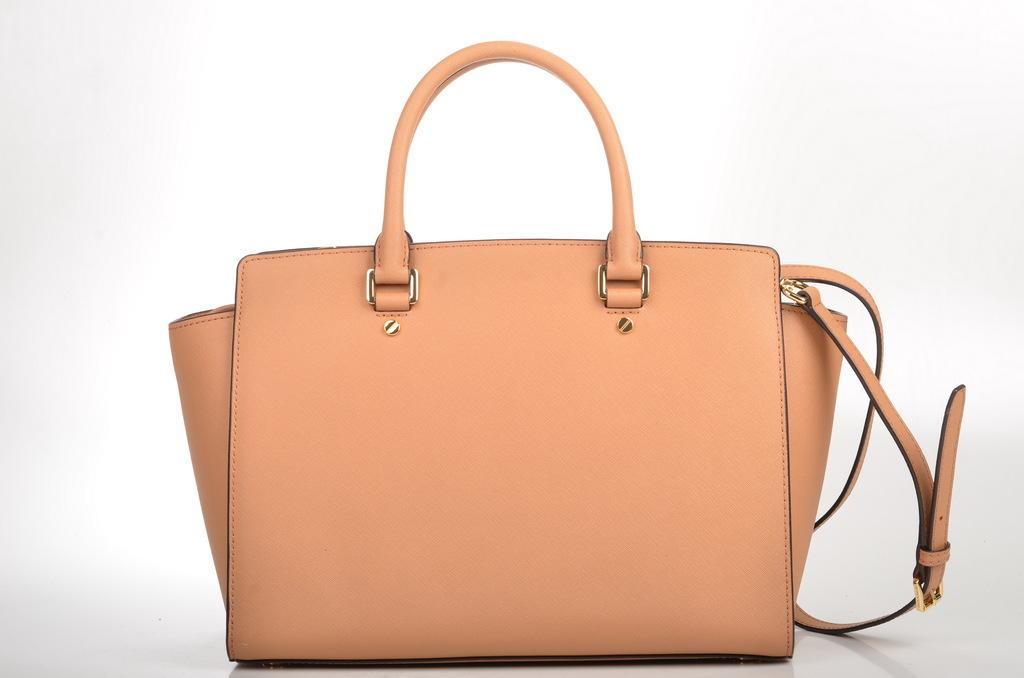What color is the handbag in the image? The handbag in the image is brown. What can be seen in the background of the image? There is a white color wall in the background of the image. What type of toy is being rewarded by the crook in the image? There is no toy or crook present in the image; it only features a brown handbag and a white wall in the background. 